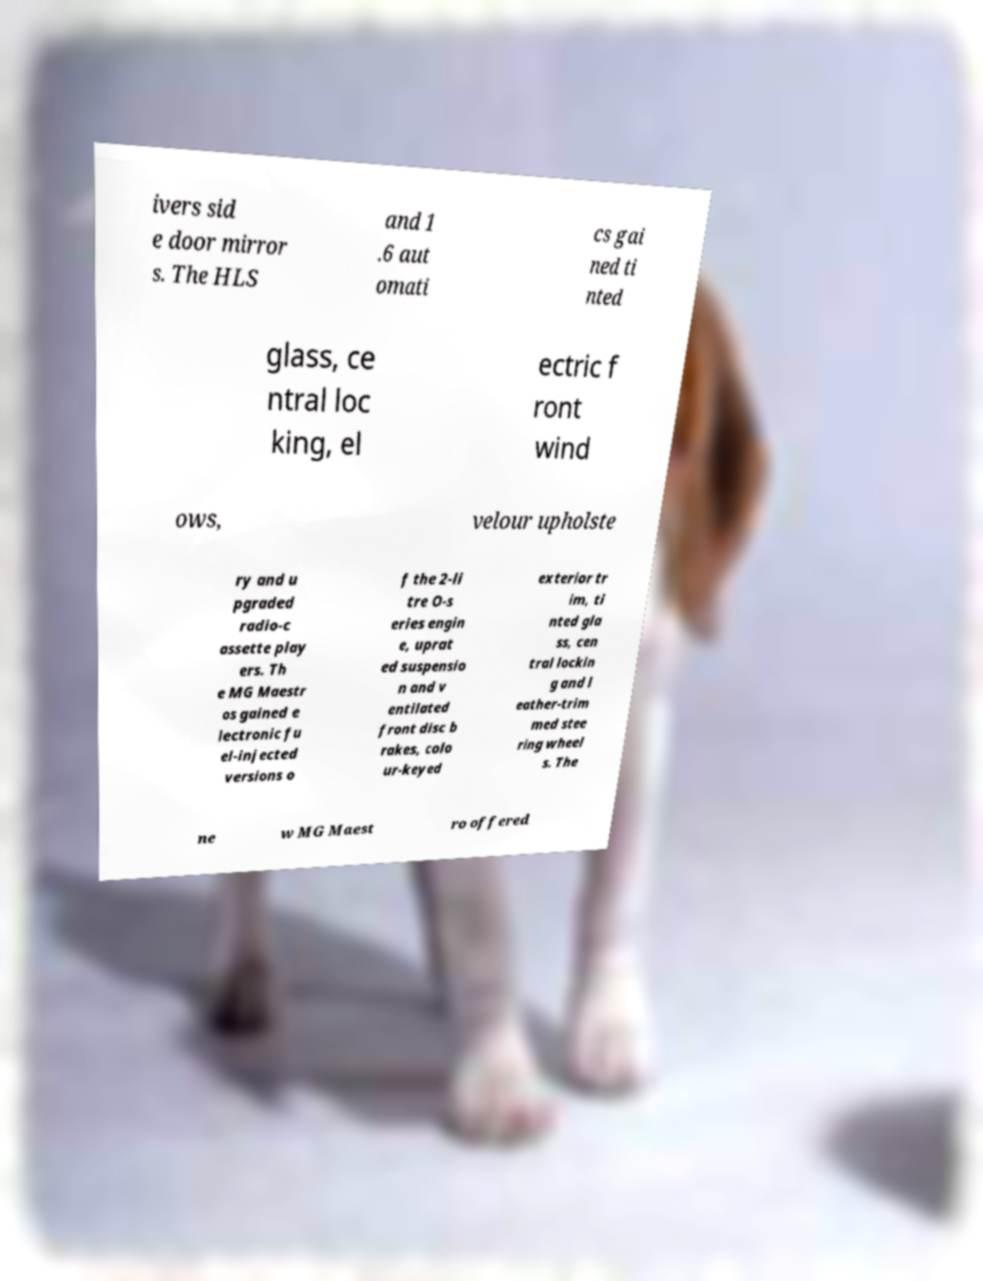What messages or text are displayed in this image? I need them in a readable, typed format. ivers sid e door mirror s. The HLS and 1 .6 aut omati cs gai ned ti nted glass, ce ntral loc king, el ectric f ront wind ows, velour upholste ry and u pgraded radio-c assette play ers. Th e MG Maestr os gained e lectronic fu el-injected versions o f the 2-li tre O-s eries engin e, uprat ed suspensio n and v entilated front disc b rakes, colo ur-keyed exterior tr im, ti nted gla ss, cen tral lockin g and l eather-trim med stee ring wheel s. The ne w MG Maest ro offered 